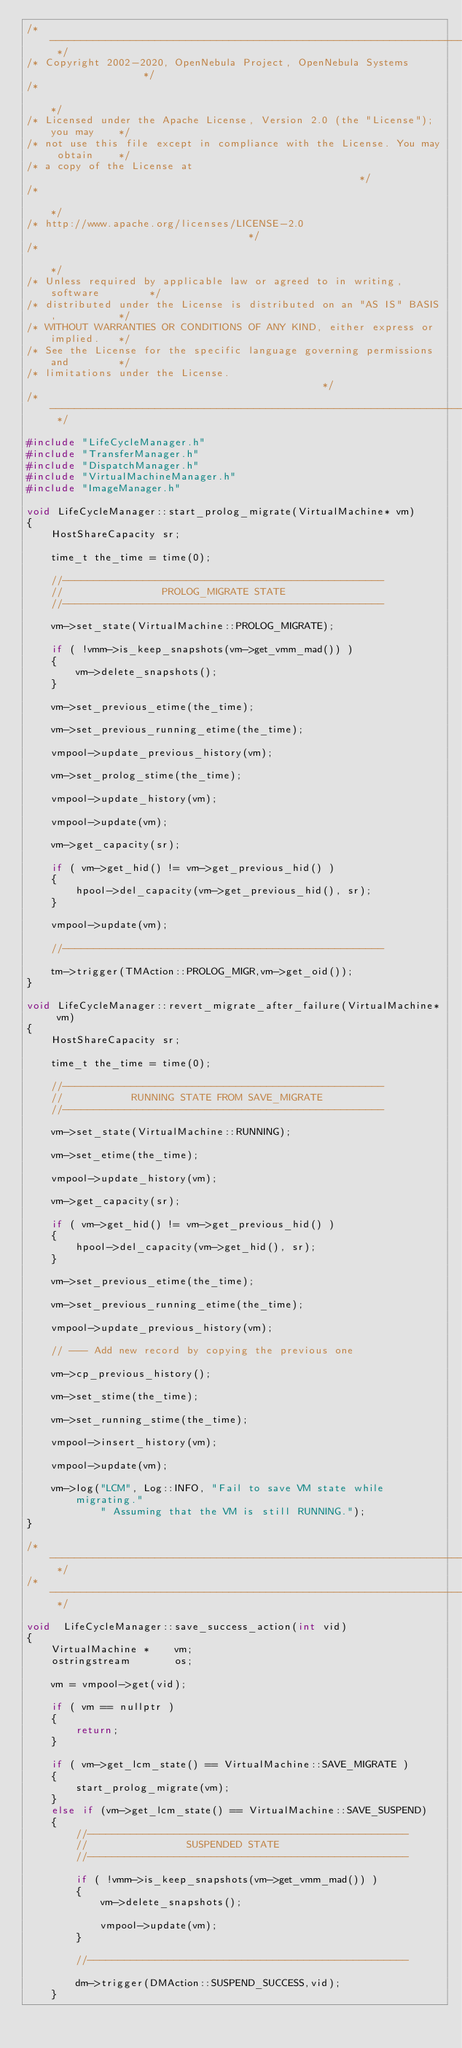Convert code to text. <code><loc_0><loc_0><loc_500><loc_500><_C++_>/* -------------------------------------------------------------------------- */
/* Copyright 2002-2020, OpenNebula Project, OpenNebula Systems                */
/*                                                                            */
/* Licensed under the Apache License, Version 2.0 (the "License"); you may    */
/* not use this file except in compliance with the License. You may obtain    */
/* a copy of the License at                                                   */
/*                                                                            */
/* http://www.apache.org/licenses/LICENSE-2.0                                 */
/*                                                                            */
/* Unless required by applicable law or agreed to in writing, software        */
/* distributed under the License is distributed on an "AS IS" BASIS,          */
/* WITHOUT WARRANTIES OR CONDITIONS OF ANY KIND, either express or implied.   */
/* See the License for the specific language governing permissions and        */
/* limitations under the License.                                             */
/* -------------------------------------------------------------------------- */

#include "LifeCycleManager.h"
#include "TransferManager.h"
#include "DispatchManager.h"
#include "VirtualMachineManager.h"
#include "ImageManager.h"

void LifeCycleManager::start_prolog_migrate(VirtualMachine* vm)
{
    HostShareCapacity sr;

    time_t the_time = time(0);

    //----------------------------------------------------
    //                PROLOG_MIGRATE STATE
    //----------------------------------------------------

    vm->set_state(VirtualMachine::PROLOG_MIGRATE);

    if ( !vmm->is_keep_snapshots(vm->get_vmm_mad()) )
    {
        vm->delete_snapshots();
    }

    vm->set_previous_etime(the_time);

    vm->set_previous_running_etime(the_time);

    vmpool->update_previous_history(vm);

    vm->set_prolog_stime(the_time);

    vmpool->update_history(vm);

    vmpool->update(vm);

    vm->get_capacity(sr);

    if ( vm->get_hid() != vm->get_previous_hid() )
    {
        hpool->del_capacity(vm->get_previous_hid(), sr);
    }

    vmpool->update(vm);

    //----------------------------------------------------

    tm->trigger(TMAction::PROLOG_MIGR,vm->get_oid());
}

void LifeCycleManager::revert_migrate_after_failure(VirtualMachine* vm)
{
    HostShareCapacity sr;

    time_t the_time = time(0);

    //----------------------------------------------------
    //           RUNNING STATE FROM SAVE_MIGRATE
    //----------------------------------------------------

    vm->set_state(VirtualMachine::RUNNING);

    vm->set_etime(the_time);

    vmpool->update_history(vm);

    vm->get_capacity(sr);

    if ( vm->get_hid() != vm->get_previous_hid() )
    {
        hpool->del_capacity(vm->get_hid(), sr);
    }

    vm->set_previous_etime(the_time);

    vm->set_previous_running_etime(the_time);

    vmpool->update_previous_history(vm);

    // --- Add new record by copying the previous one

    vm->cp_previous_history();

    vm->set_stime(the_time);

    vm->set_running_stime(the_time);

    vmpool->insert_history(vm);

    vmpool->update(vm);

    vm->log("LCM", Log::INFO, "Fail to save VM state while migrating."
            " Assuming that the VM is still RUNNING.");
}

/* -------------------------------------------------------------------------- */
/* -------------------------------------------------------------------------- */

void  LifeCycleManager::save_success_action(int vid)
{
    VirtualMachine *    vm;
    ostringstream       os;

    vm = vmpool->get(vid);

    if ( vm == nullptr )
    {
        return;
    }

    if ( vm->get_lcm_state() == VirtualMachine::SAVE_MIGRATE )
    {
        start_prolog_migrate(vm);
    }
    else if (vm->get_lcm_state() == VirtualMachine::SAVE_SUSPEND)
    {
        //----------------------------------------------------
        //                SUSPENDED STATE
        //----------------------------------------------------

        if ( !vmm->is_keep_snapshots(vm->get_vmm_mad()) )
        {
            vm->delete_snapshots();

            vmpool->update(vm);
        }

        //----------------------------------------------------

        dm->trigger(DMAction::SUSPEND_SUCCESS,vid);
    }</code> 